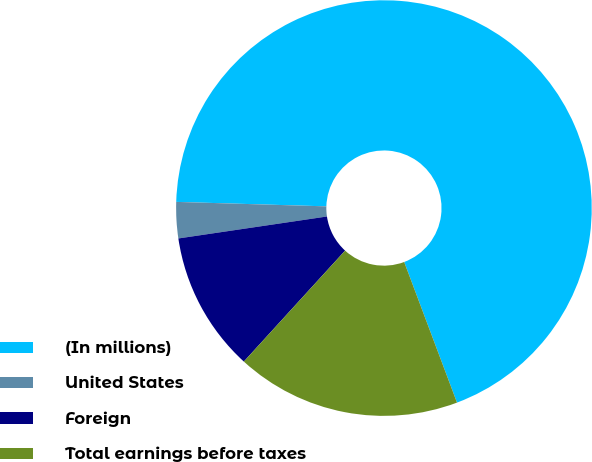Convert chart to OTSL. <chart><loc_0><loc_0><loc_500><loc_500><pie_chart><fcel>(In millions)<fcel>United States<fcel>Foreign<fcel>Total earnings before taxes<nl><fcel>68.8%<fcel>2.81%<fcel>10.89%<fcel>17.49%<nl></chart> 